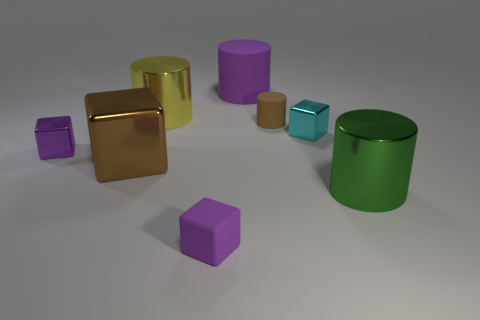Does the purple rubber cube have the same size as the shiny cube to the left of the brown shiny object?
Offer a terse response. Yes. How many things are either big things that are to the right of the small cyan object or purple blocks that are on the right side of the brown block?
Your answer should be very brief. 2. There is a cylinder in front of the big brown object; what color is it?
Give a very brief answer. Green. There is a rubber cylinder that is behind the small cylinder; are there any green metallic things to the left of it?
Your answer should be very brief. No. Are there fewer small gray cubes than large green shiny cylinders?
Offer a very short reply. Yes. What is the material of the brown object that is in front of the small purple block on the left side of the big brown metal block?
Offer a terse response. Metal. Do the purple metallic thing and the brown metallic object have the same size?
Ensure brevity in your answer.  No. What number of objects are either purple metallic blocks or small brown things?
Provide a succinct answer. 2. There is a purple thing that is both on the right side of the brown metal object and behind the tiny purple rubber object; what size is it?
Offer a terse response. Large. Are there fewer large green metallic cylinders behind the big brown thing than tiny purple metallic objects?
Offer a terse response. Yes. 